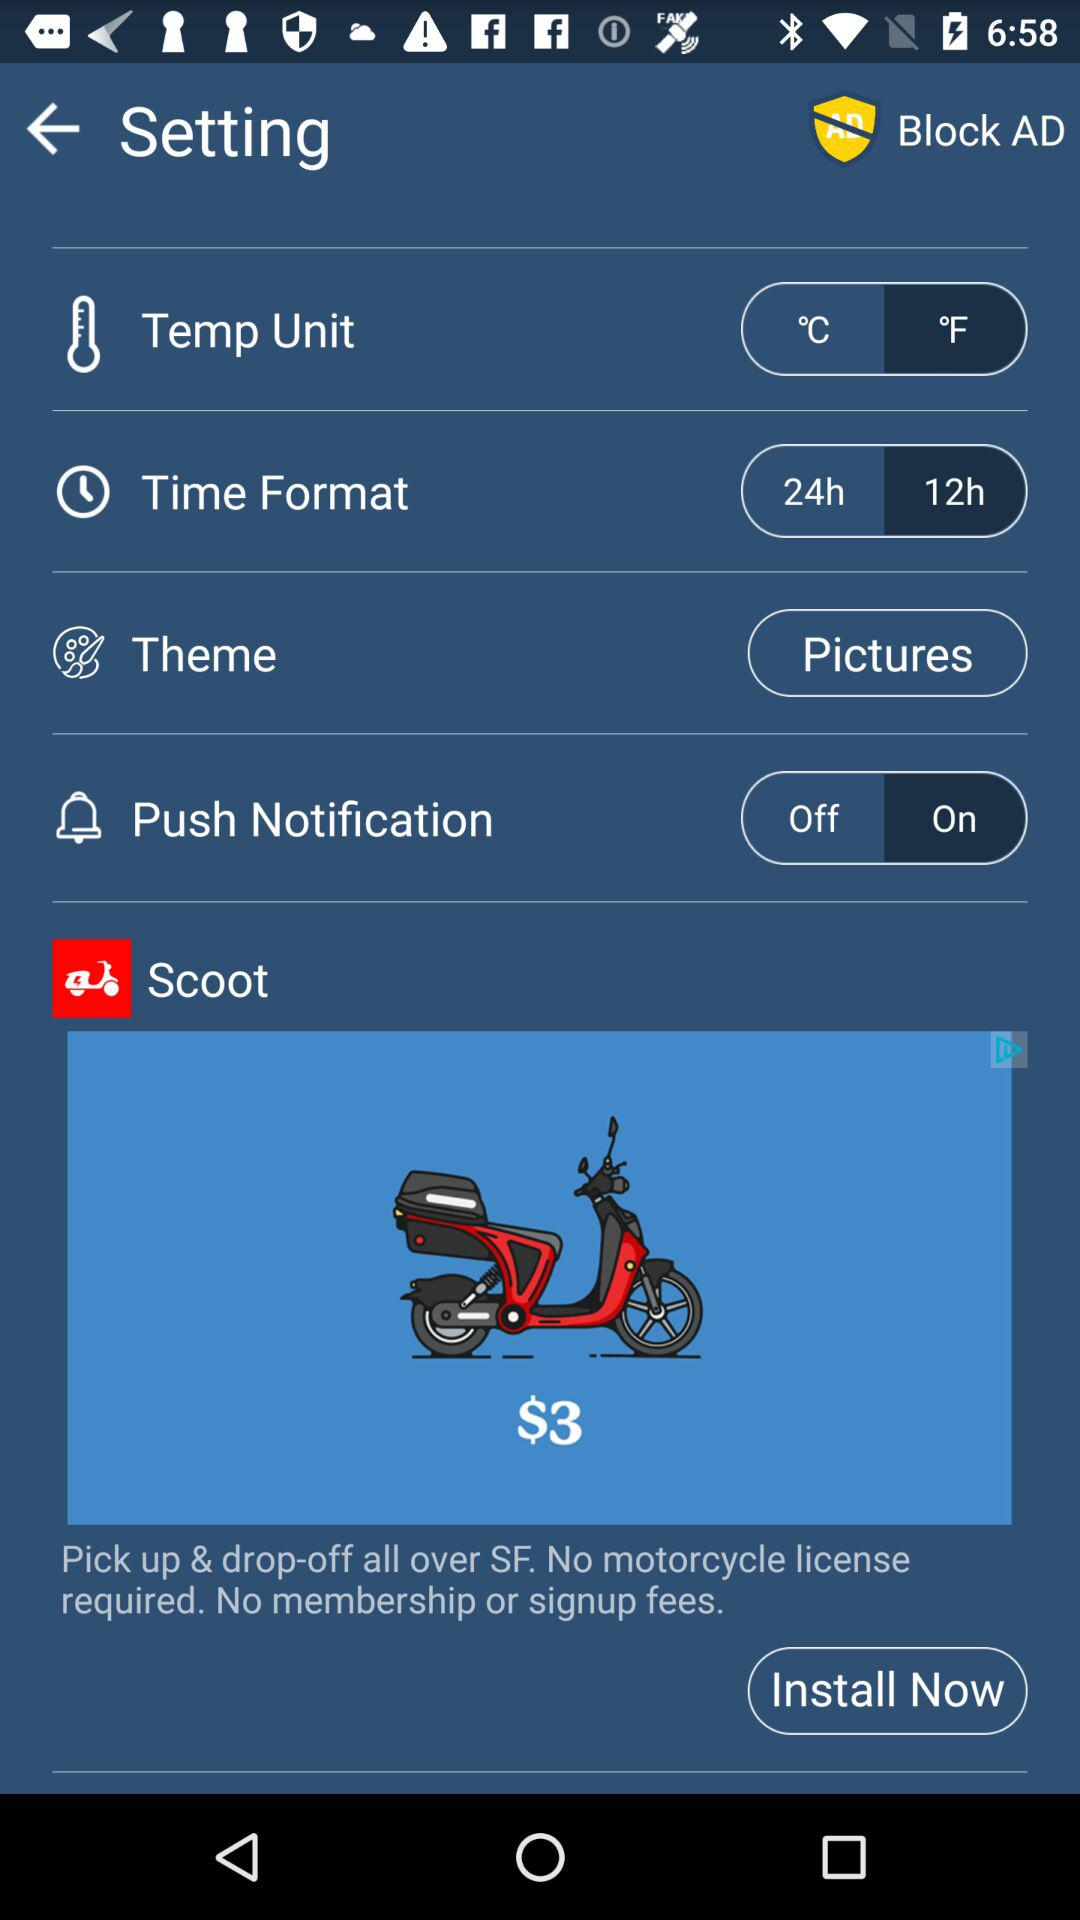What is the selected unit of temperature? The selected unit is °F. 